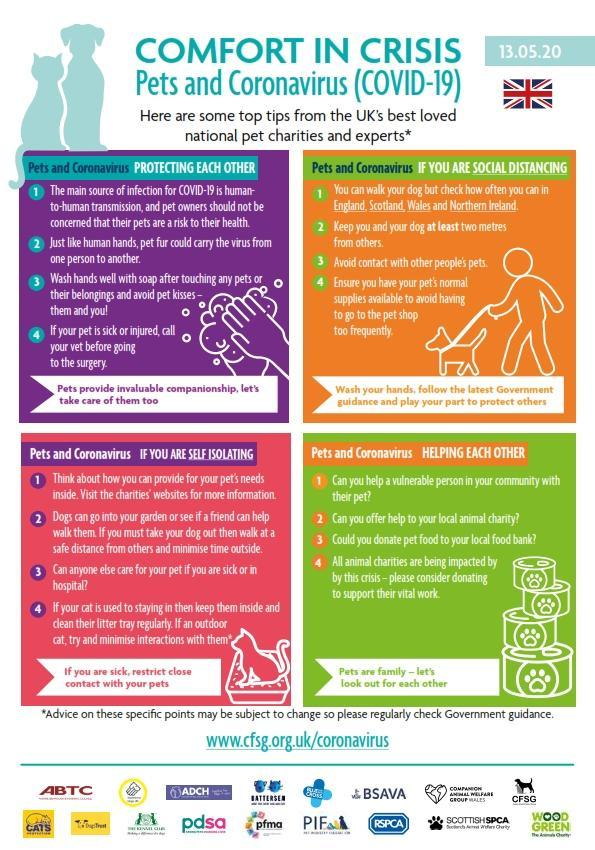How many points are under the heading "Pets and Coronavirus helping each other"?
Answer the question with a short phrase. 4 How many points are under the heading "Pets and Coronavirus protecting each other"? 4 